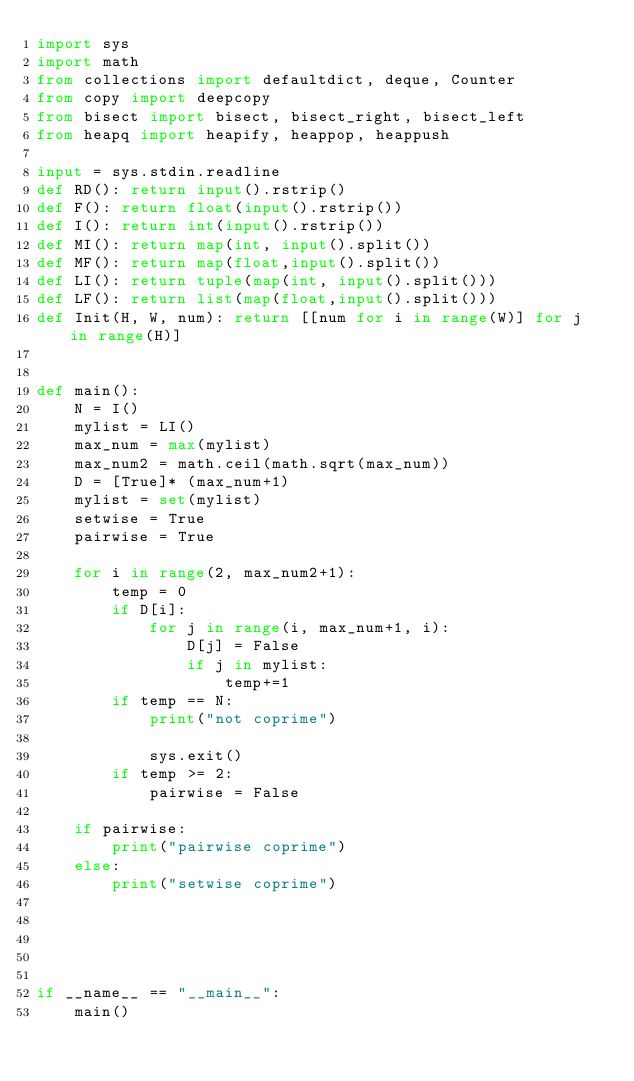<code> <loc_0><loc_0><loc_500><loc_500><_Python_>import sys
import math
from collections import defaultdict, deque, Counter
from copy import deepcopy
from bisect import bisect, bisect_right, bisect_left
from heapq import heapify, heappop, heappush
    
input = sys.stdin.readline
def RD(): return input().rstrip()
def F(): return float(input().rstrip())
def I(): return int(input().rstrip())
def MI(): return map(int, input().split())
def MF(): return map(float,input().split())
def LI(): return tuple(map(int, input().split()))
def LF(): return list(map(float,input().split()))
def Init(H, W, num): return [[num for i in range(W)] for j in range(H)]
    
    
def main():
    N = I()
    mylist = LI()
    max_num = max(mylist)
    max_num2 = math.ceil(math.sqrt(max_num))
    D = [True]* (max_num+1)
    mylist = set(mylist)
    setwise = True
    pairwise = True

    for i in range(2, max_num2+1):
        temp = 0
        if D[i]:
            for j in range(i, max_num+1, i):
                D[j] = False
                if j in mylist:
                    temp+=1
        if temp == N:
            print("not coprime")
            
            sys.exit()
        if temp >= 2:
            pairwise = False

    if pairwise:
        print("pairwise coprime")
    else:
        print("setwise coprime")
                    

            
    
    
if __name__ == "__main__":
    main()</code> 